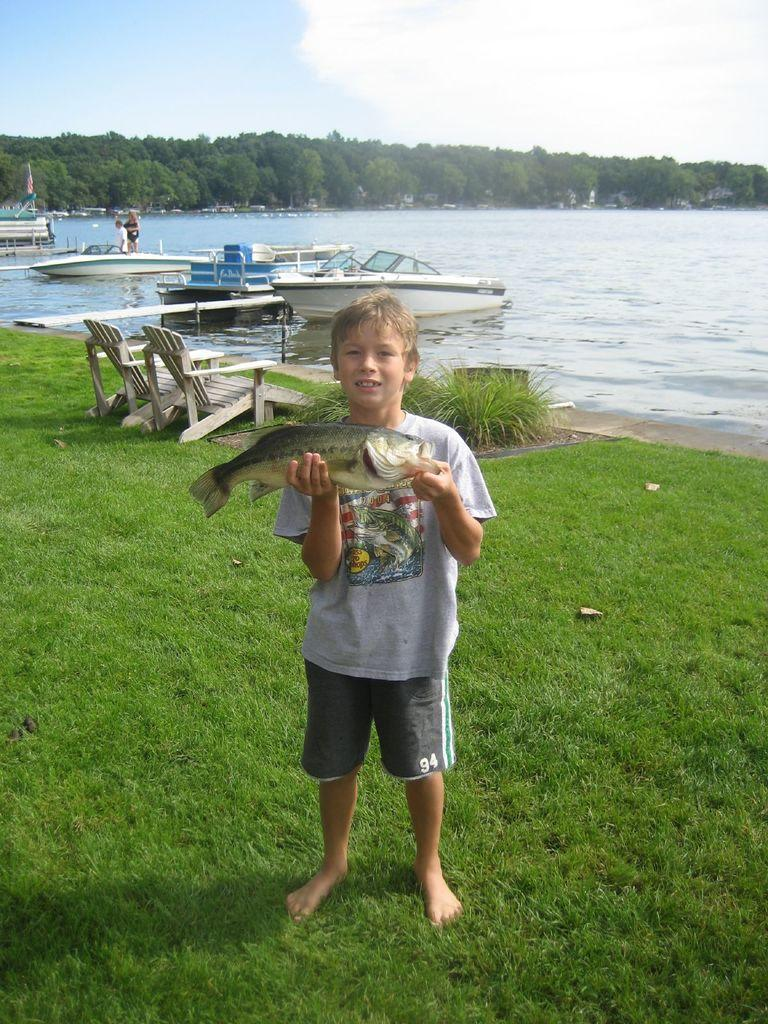Who is in the picture? There is a boy in the picture. What is the boy doing in the picture? The boy is catching a fish. What can be seen in the water in the picture? There are boats in the water. What type of seating is available on the grass in the picture? There are benches on the grass. What type of vegetation is visible in the image? There are trees visible in the image. What is the condition of the sky in the picture? The sky is clear in the picture. What type of lipstick is the boy wearing in the picture? There is no lipstick or indication of the boy wearing lipstick in the picture. 